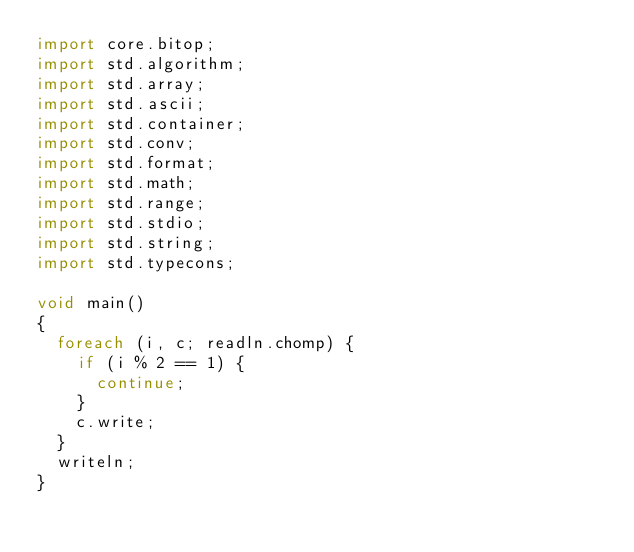Convert code to text. <code><loc_0><loc_0><loc_500><loc_500><_D_>import core.bitop;
import std.algorithm;
import std.array;
import std.ascii;
import std.container;
import std.conv;
import std.format;
import std.math;
import std.range;
import std.stdio;
import std.string;
import std.typecons;

void main()
{
  foreach (i, c; readln.chomp) {
    if (i % 2 == 1) {
      continue;
    }
    c.write;
  }
  writeln;
}
</code> 